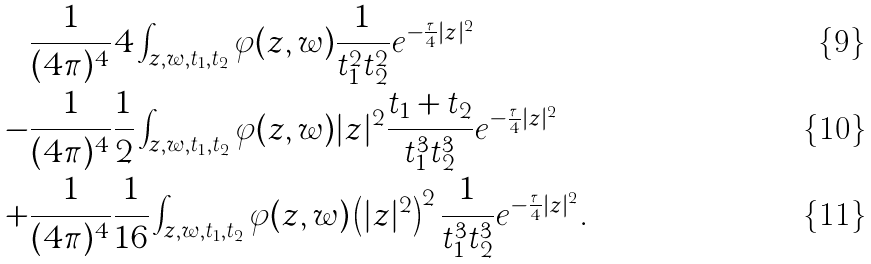Convert formula to latex. <formula><loc_0><loc_0><loc_500><loc_500>& \frac { 1 } { ( 4 \pi ) ^ { 4 } } 4 \int _ { z , w , t _ { 1 } , t _ { 2 } } \varphi ( z , w ) \frac { 1 } { t _ { 1 } ^ { 2 } t _ { 2 } ^ { 2 } } e ^ { - \frac { \tau } { 4 } | z | ^ { 2 } } \\ - & \frac { 1 } { ( 4 \pi ) ^ { 4 } } \frac { 1 } { 2 } \int _ { z , w , t _ { 1 } , t _ { 2 } } \varphi ( z , w ) | z | ^ { 2 } \frac { t _ { 1 } + t _ { 2 } } { t _ { 1 } ^ { 3 } t _ { 2 } ^ { 3 } } e ^ { - \frac { \tau } { 4 } | z | ^ { 2 } } \\ + & \frac { 1 } { ( 4 \pi ) ^ { 4 } } \frac { 1 } { 1 6 } \int _ { z , w , t _ { 1 } , t _ { 2 } } \varphi ( z , w ) \left ( | z | ^ { 2 } \right ) ^ { 2 } \frac { 1 } { t _ { 1 } ^ { 3 } t _ { 2 } ^ { 3 } } e ^ { - \frac { \tau } { 4 } | z | ^ { 2 } } .</formula> 